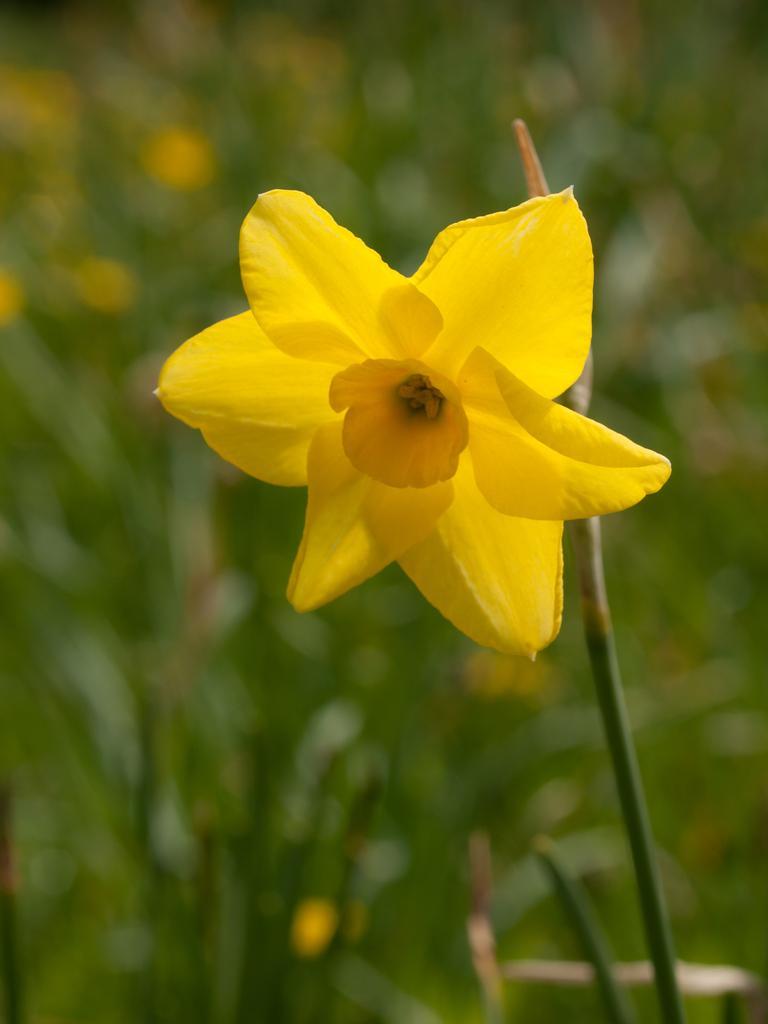Describe this image in one or two sentences. In this image in the front there is a flower and the background is blurry. 